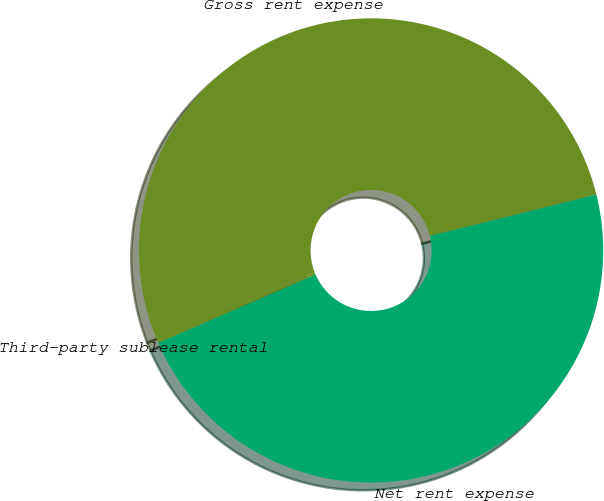Convert chart. <chart><loc_0><loc_0><loc_500><loc_500><pie_chart><fcel>Gross rent expense<fcel>Third-party sublease rental<fcel>Net rent expense<nl><fcel>52.07%<fcel>0.59%<fcel>47.34%<nl></chart> 